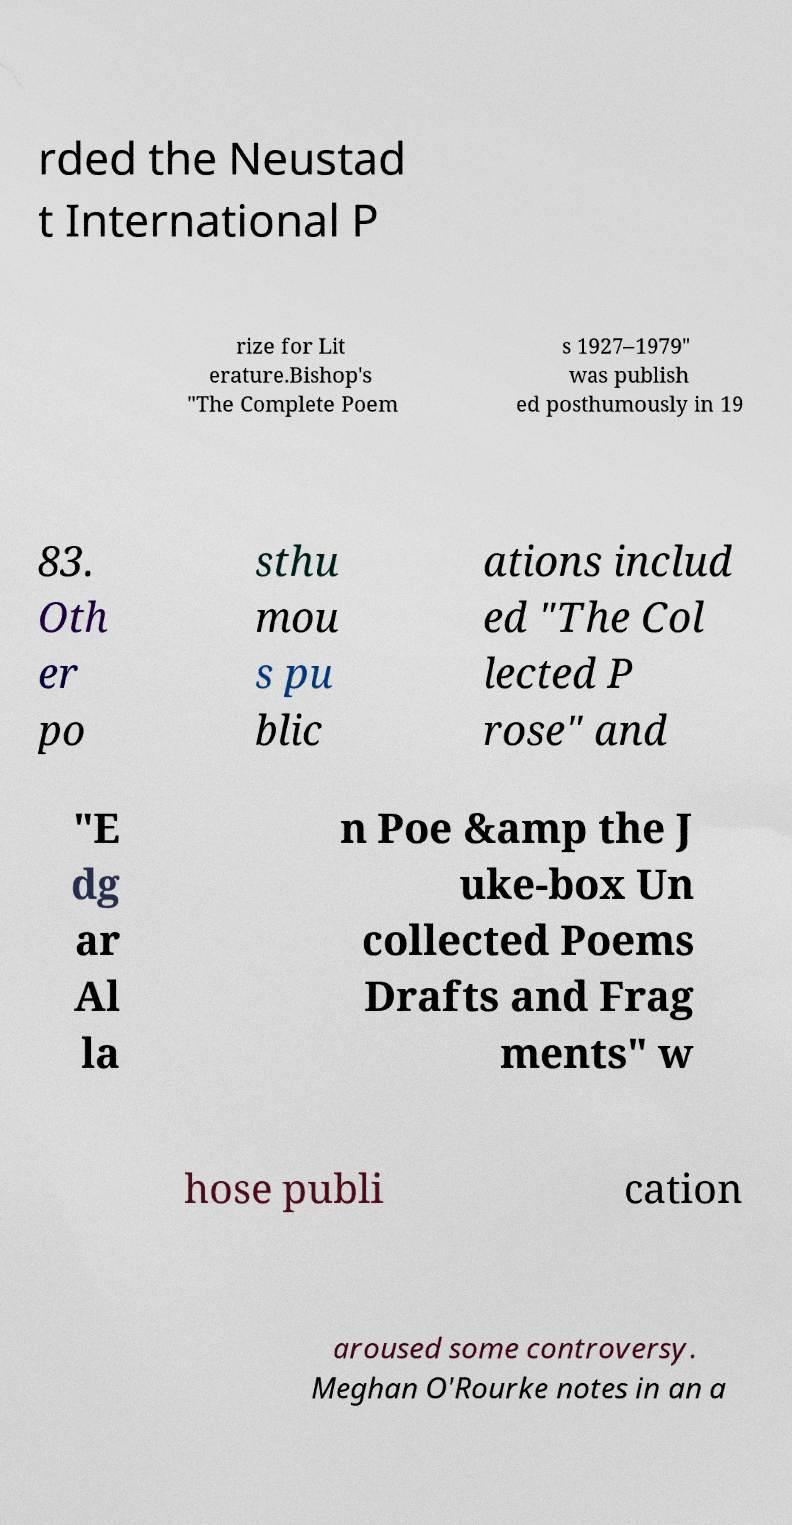Please read and relay the text visible in this image. What does it say? rded the Neustad t International P rize for Lit erature.Bishop's "The Complete Poem s 1927–1979" was publish ed posthumously in 19 83. Oth er po sthu mou s pu blic ations includ ed "The Col lected P rose" and "E dg ar Al la n Poe &amp the J uke-box Un collected Poems Drafts and Frag ments" w hose publi cation aroused some controversy. Meghan O'Rourke notes in an a 